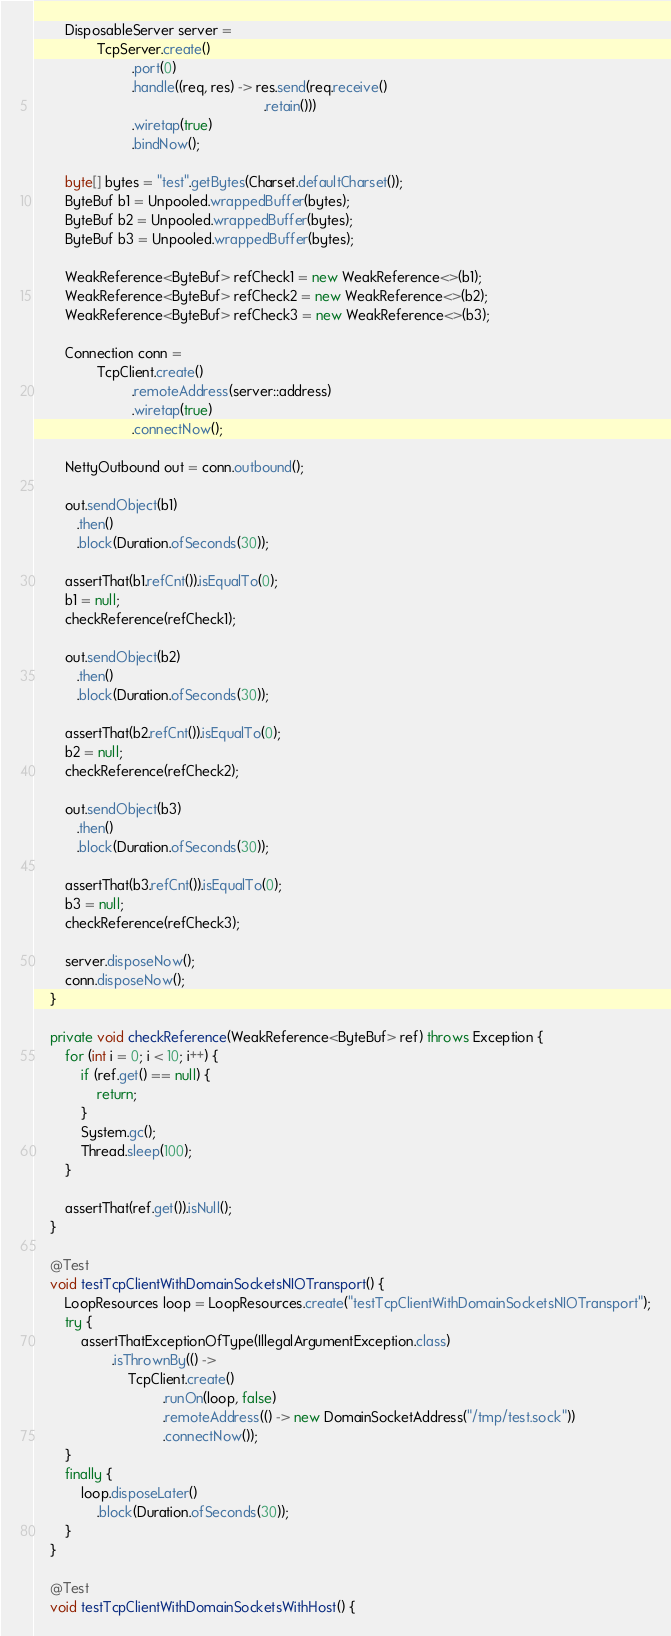Convert code to text. <code><loc_0><loc_0><loc_500><loc_500><_Java_>		DisposableServer server =
				TcpServer.create()
				         .port(0)
				         .handle((req, res) -> res.send(req.receive()
				                                           .retain()))
				         .wiretap(true)
				         .bindNow();

		byte[] bytes = "test".getBytes(Charset.defaultCharset());
		ByteBuf b1 = Unpooled.wrappedBuffer(bytes);
		ByteBuf b2 = Unpooled.wrappedBuffer(bytes);
		ByteBuf b3 = Unpooled.wrappedBuffer(bytes);

		WeakReference<ByteBuf> refCheck1 = new WeakReference<>(b1);
		WeakReference<ByteBuf> refCheck2 = new WeakReference<>(b2);
		WeakReference<ByteBuf> refCheck3 = new WeakReference<>(b3);

		Connection conn =
				TcpClient.create()
				         .remoteAddress(server::address)
				         .wiretap(true)
				         .connectNow();

		NettyOutbound out = conn.outbound();

		out.sendObject(b1)
		   .then()
		   .block(Duration.ofSeconds(30));

		assertThat(b1.refCnt()).isEqualTo(0);
		b1 = null;
		checkReference(refCheck1);

		out.sendObject(b2)
		   .then()
		   .block(Duration.ofSeconds(30));

		assertThat(b2.refCnt()).isEqualTo(0);
		b2 = null;
		checkReference(refCheck2);

		out.sendObject(b3)
		   .then()
		   .block(Duration.ofSeconds(30));

		assertThat(b3.refCnt()).isEqualTo(0);
		b3 = null;
		checkReference(refCheck3);

		server.disposeNow();
		conn.disposeNow();
	}

	private void checkReference(WeakReference<ByteBuf> ref) throws Exception {
		for (int i = 0; i < 10; i++) {
			if (ref.get() == null) {
				return;
			}
			System.gc();
			Thread.sleep(100);
		}

		assertThat(ref.get()).isNull();
	}

	@Test
	void testTcpClientWithDomainSocketsNIOTransport() {
		LoopResources loop = LoopResources.create("testTcpClientWithDomainSocketsNIOTransport");
		try {
			assertThatExceptionOfType(IllegalArgumentException.class)
					.isThrownBy(() ->
						TcpClient.create()
						         .runOn(loop, false)
						         .remoteAddress(() -> new DomainSocketAddress("/tmp/test.sock"))
						         .connectNow());
		}
		finally {
			loop.disposeLater()
			    .block(Duration.ofSeconds(30));
		}
	}

	@Test
	void testTcpClientWithDomainSocketsWithHost() {</code> 